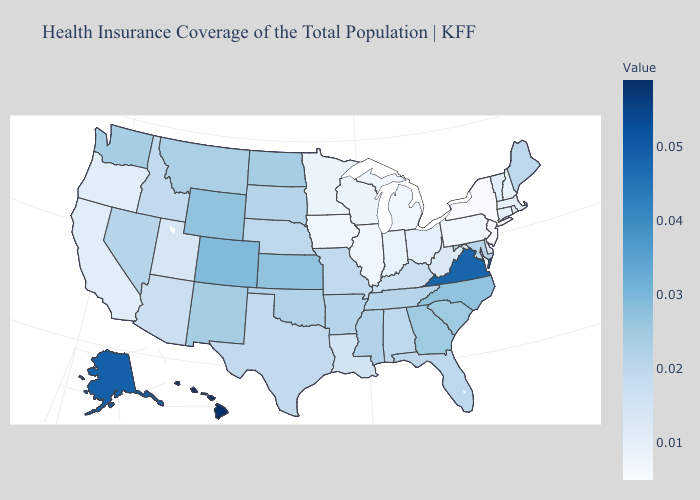Does Vermont have a higher value than Idaho?
Short answer required. No. Among the states that border Washington , which have the lowest value?
Write a very short answer. Oregon. Does Hawaii have the highest value in the USA?
Quick response, please. Yes. Does South Carolina have a higher value than Connecticut?
Keep it brief. Yes. Which states have the highest value in the USA?
Concise answer only. Hawaii. Which states hav the highest value in the Northeast?
Answer briefly. Maine. Which states hav the highest value in the MidWest?
Answer briefly. Kansas. 